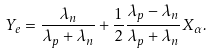<formula> <loc_0><loc_0><loc_500><loc_500>Y _ { e } = \frac { \lambda _ { n } } { \lambda _ { p } + \lambda _ { n } } + \frac { 1 } { 2 } \frac { \lambda _ { p } - \lambda _ { n } } { \lambda _ { p } + \lambda _ { n } } X _ { \alpha } .</formula> 